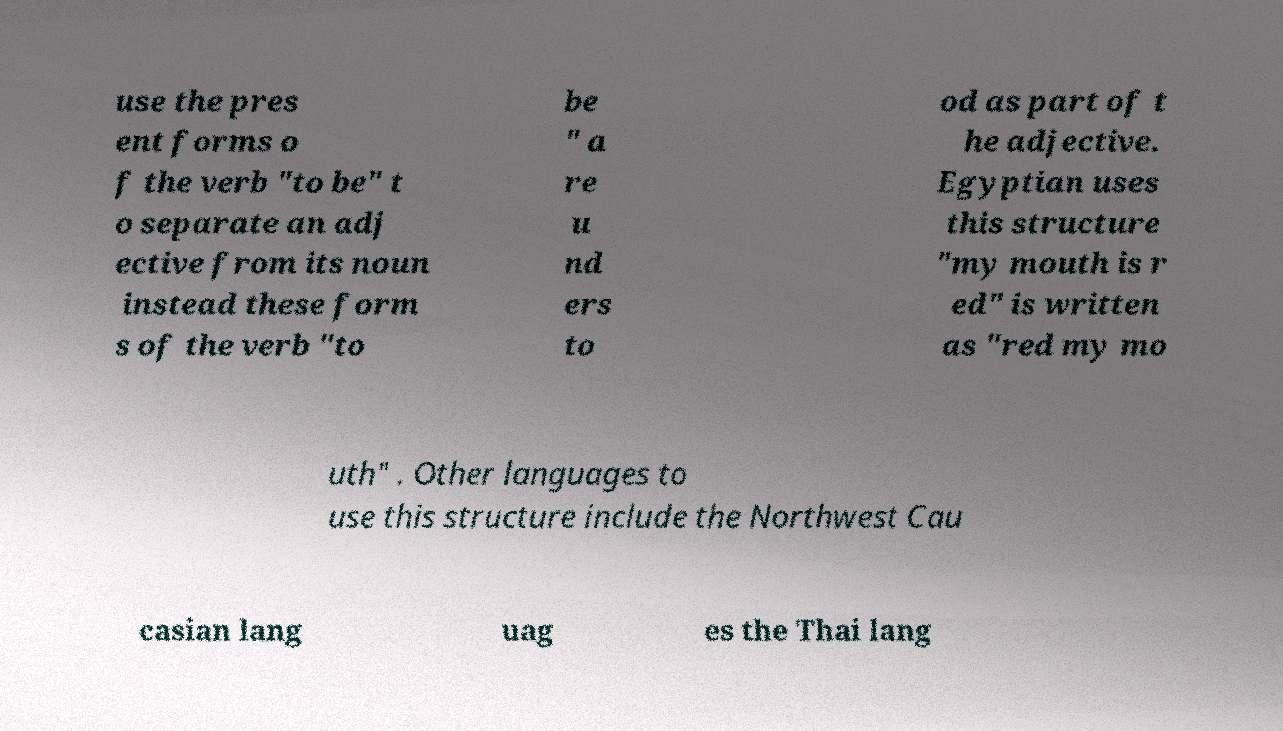Could you extract and type out the text from this image? use the pres ent forms o f the verb "to be" t o separate an adj ective from its noun instead these form s of the verb "to be " a re u nd ers to od as part of t he adjective. Egyptian uses this structure "my mouth is r ed" is written as "red my mo uth" . Other languages to use this structure include the Northwest Cau casian lang uag es the Thai lang 